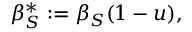Convert formula to latex. <formula><loc_0><loc_0><loc_500><loc_500>\beta _ { S } ^ { * } \mathop \colon = \beta _ { S } ( 1 - u ) ,</formula> 